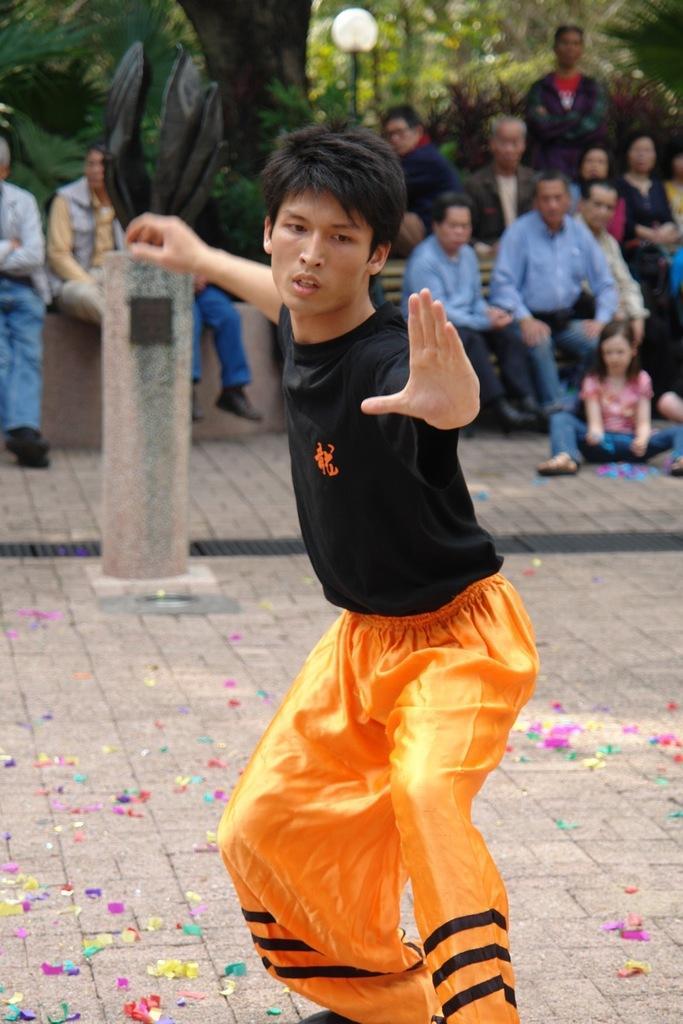In one or two sentences, can you explain what this image depicts? This image consists of a man doing martial art. At the bottom, there is a ground. In the background, we can see many persons sitting. And there are trees and plants. 